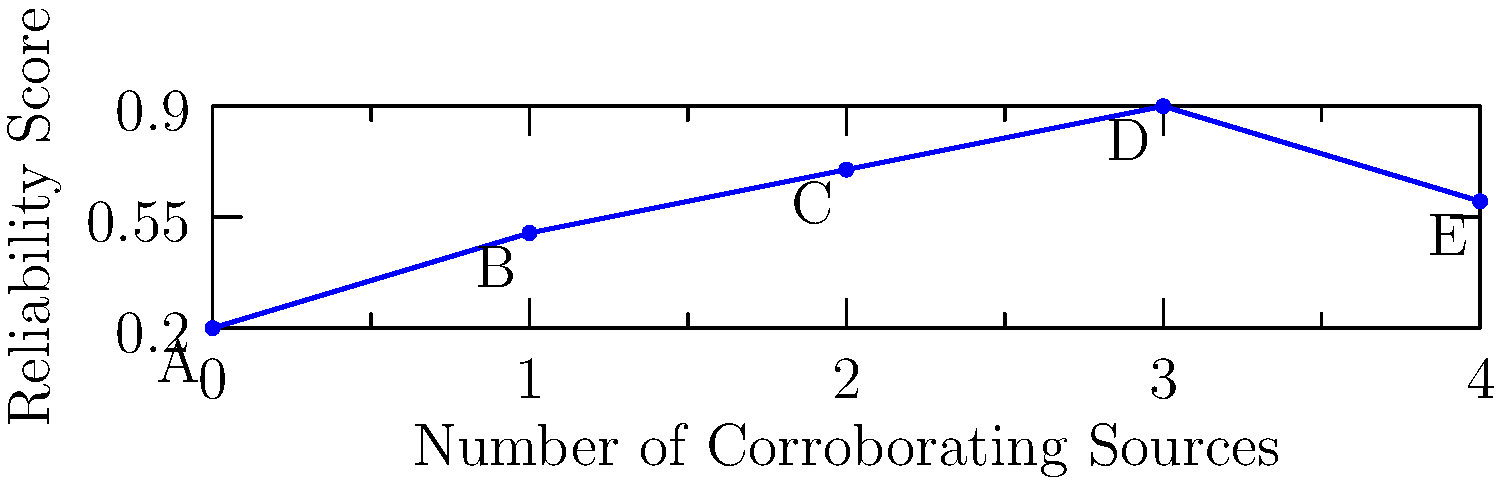Based on the chart comparing the reliability of historical accounts with the number of corroborating sources, which account (A, B, C, D, or E) demonstrates the principle that more corroboration does not always guarantee higher reliability? Explain your reasoning using the data presented. To answer this question, we need to analyze the relationship between the number of corroborating sources and the reliability score for each historical account:

1. Account A: 0 corroborating sources, reliability score of 0.2
2. Account B: 1 corroborating source, reliability score of 0.5
3. Account C: 2 corroborating sources, reliability score of 0.7
4. Account D: 3 corroborating sources, reliability score of 0.9
5. Account E: 4 corroborating sources, reliability score of 0.6

The general trend shows that reliability increases with more corroborating sources from A to D. However, Account E breaks this pattern:

- E has more corroborating sources (4) than D (3)
- E has a lower reliability score (0.6) than D (0.9)

This demonstrates that more corroboration doesn't always guarantee higher reliability. Account E has the most corroborating sources but is considered less reliable than accounts C and D, which have fewer sources.

This principle is crucial in historical research, as it reminds us to consider the quality and context of sources, not just their quantity.
Answer: Account E 